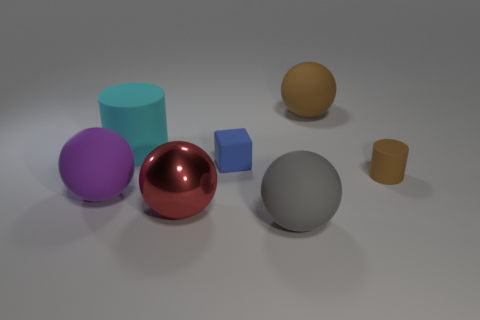What shape is the blue thing right of the big shiny object? cube 